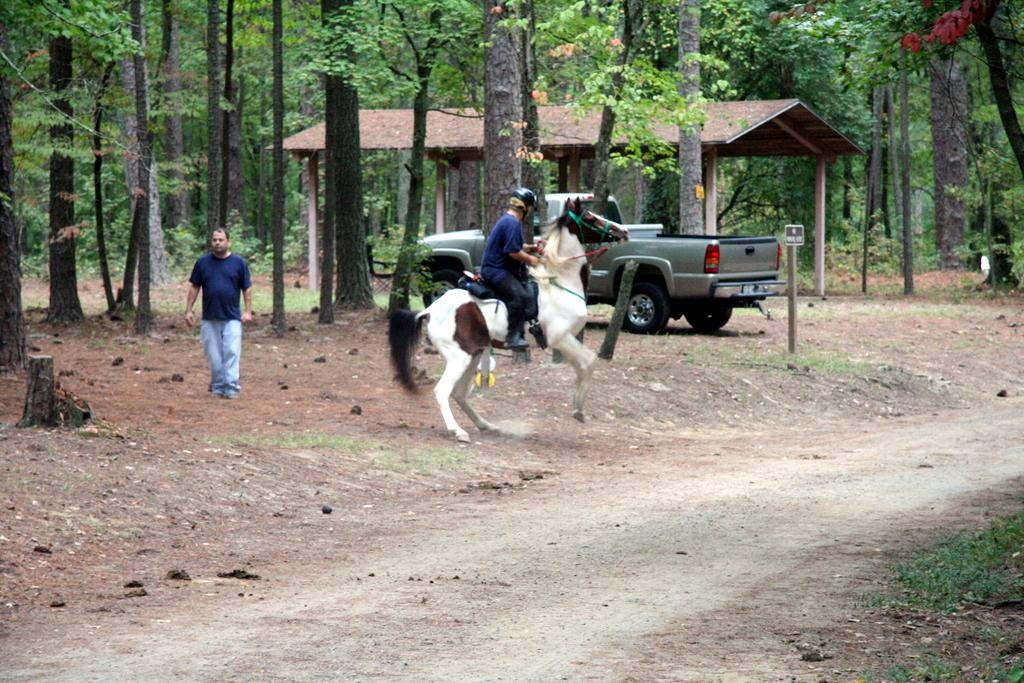What is the person in the image doing? There is a person riding a white horse in the image. What is the other person in the image doing? There is a person walking in the image. What can be seen parked in the image? There is a vehicle parked in the image. What type of structure is present in the image? There is a wooden hut in the image. What type of vegetation is visible in the image? There are trees visible in the image. What type of trade is being conducted in the image? There is no indication of any trade being conducted in the image. How does the sleet affect the person riding the horse in the image? There is no sleet present in the image; the weather appears to be clear. 